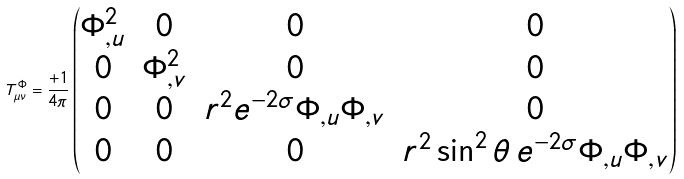<formula> <loc_0><loc_0><loc_500><loc_500>T _ { \mu \nu } ^ { \Phi } = \frac { + 1 } { 4 \pi } \begin{pmatrix} \Phi ^ { 2 } _ { , u } & 0 & 0 & 0 \\ 0 & \Phi ^ { 2 } _ { , v } & 0 & 0 \\ 0 & 0 & r ^ { 2 } e ^ { - 2 \sigma } \Phi _ { , u } \Phi _ { , v } & 0 \\ 0 & 0 & 0 & r ^ { 2 } \sin ^ { 2 } \theta \, e ^ { - 2 \sigma } \Phi _ { , u } \Phi _ { , v } \end{pmatrix}</formula> 